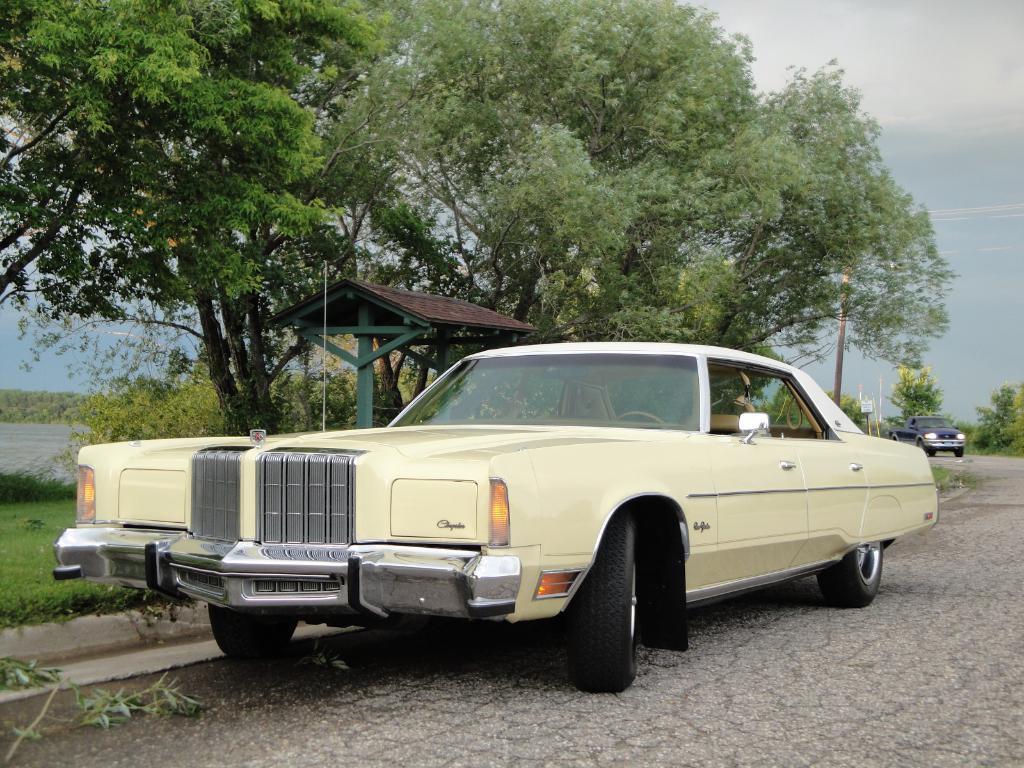How would you summarize this image in a sentence or two? In this image there are a few vehicles on the road, beside that there is a shed. On the left and right side of the image there are trees, on the left side there is a river. In the background there is a pole and the sky. 